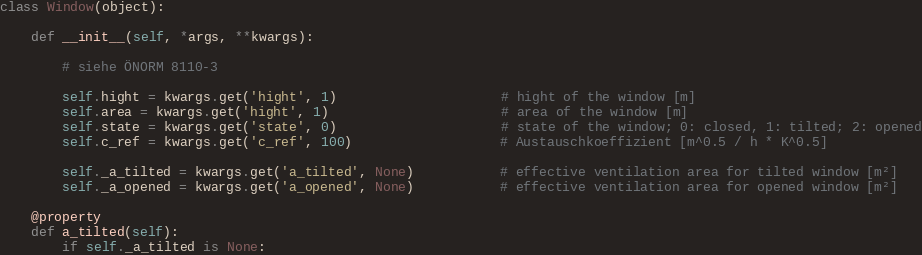<code> <loc_0><loc_0><loc_500><loc_500><_Python_>class Window(object):

    def __init__(self, *args, **kwargs):

        # siehe ÖNORM 8110-3

        self.hight = kwargs.get('hight', 1)                     # hight of the window [m]
        self.area = kwargs.get('hight', 1)                      # area of the window [m]
        self.state = kwargs.get('state', 0)                     # state of the window; 0: closed, 1: tilted; 2: opened
        self.c_ref = kwargs.get('c_ref', 100)                   # Austauschkoeffizient [m^0.5 / h * K^0.5]

        self._a_tilted = kwargs.get('a_tilted', None)           # effective ventilation area for tilted window [m²]
        self._a_opened = kwargs.get('a_opened', None)           # effective ventilation area for opened window [m²]

    @property
    def a_tilted(self):
        if self._a_tilted is None:</code> 